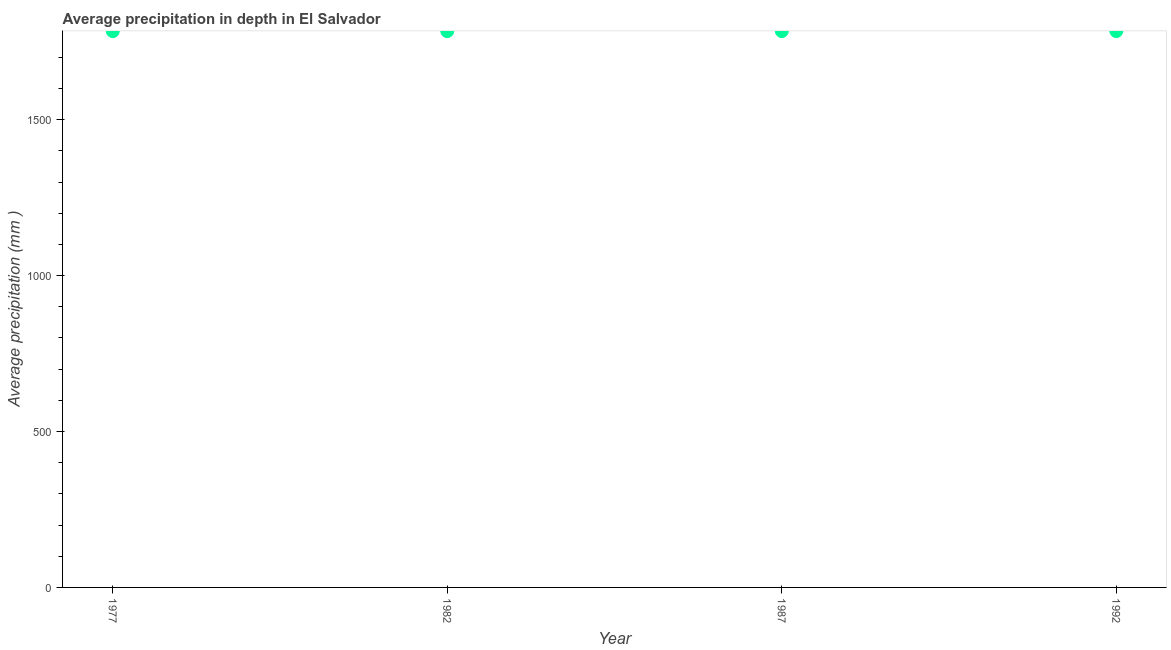What is the average precipitation in depth in 1977?
Ensure brevity in your answer.  1784. Across all years, what is the maximum average precipitation in depth?
Keep it short and to the point. 1784. Across all years, what is the minimum average precipitation in depth?
Offer a very short reply. 1784. In which year was the average precipitation in depth minimum?
Provide a short and direct response. 1977. What is the sum of the average precipitation in depth?
Your answer should be very brief. 7136. What is the average average precipitation in depth per year?
Provide a succinct answer. 1784. What is the median average precipitation in depth?
Provide a succinct answer. 1784. Do a majority of the years between 1987 and 1982 (inclusive) have average precipitation in depth greater than 900 mm?
Your answer should be compact. No. What is the ratio of the average precipitation in depth in 1982 to that in 1992?
Ensure brevity in your answer.  1. Is the sum of the average precipitation in depth in 1982 and 1987 greater than the maximum average precipitation in depth across all years?
Keep it short and to the point. Yes. What is the difference between the highest and the lowest average precipitation in depth?
Offer a very short reply. 0. Does the average precipitation in depth monotonically increase over the years?
Your answer should be very brief. No. How many years are there in the graph?
Your answer should be very brief. 4. What is the difference between two consecutive major ticks on the Y-axis?
Provide a succinct answer. 500. Does the graph contain any zero values?
Give a very brief answer. No. What is the title of the graph?
Your answer should be very brief. Average precipitation in depth in El Salvador. What is the label or title of the X-axis?
Ensure brevity in your answer.  Year. What is the label or title of the Y-axis?
Your answer should be very brief. Average precipitation (mm ). What is the Average precipitation (mm ) in 1977?
Your answer should be very brief. 1784. What is the Average precipitation (mm ) in 1982?
Offer a terse response. 1784. What is the Average precipitation (mm ) in 1987?
Provide a succinct answer. 1784. What is the Average precipitation (mm ) in 1992?
Your response must be concise. 1784. What is the difference between the Average precipitation (mm ) in 1977 and 1992?
Keep it short and to the point. 0. What is the difference between the Average precipitation (mm ) in 1987 and 1992?
Provide a succinct answer. 0. What is the ratio of the Average precipitation (mm ) in 1977 to that in 1982?
Your answer should be very brief. 1. What is the ratio of the Average precipitation (mm ) in 1977 to that in 1987?
Your response must be concise. 1. What is the ratio of the Average precipitation (mm ) in 1977 to that in 1992?
Your answer should be compact. 1. What is the ratio of the Average precipitation (mm ) in 1982 to that in 1987?
Your response must be concise. 1. What is the ratio of the Average precipitation (mm ) in 1982 to that in 1992?
Keep it short and to the point. 1. What is the ratio of the Average precipitation (mm ) in 1987 to that in 1992?
Provide a short and direct response. 1. 